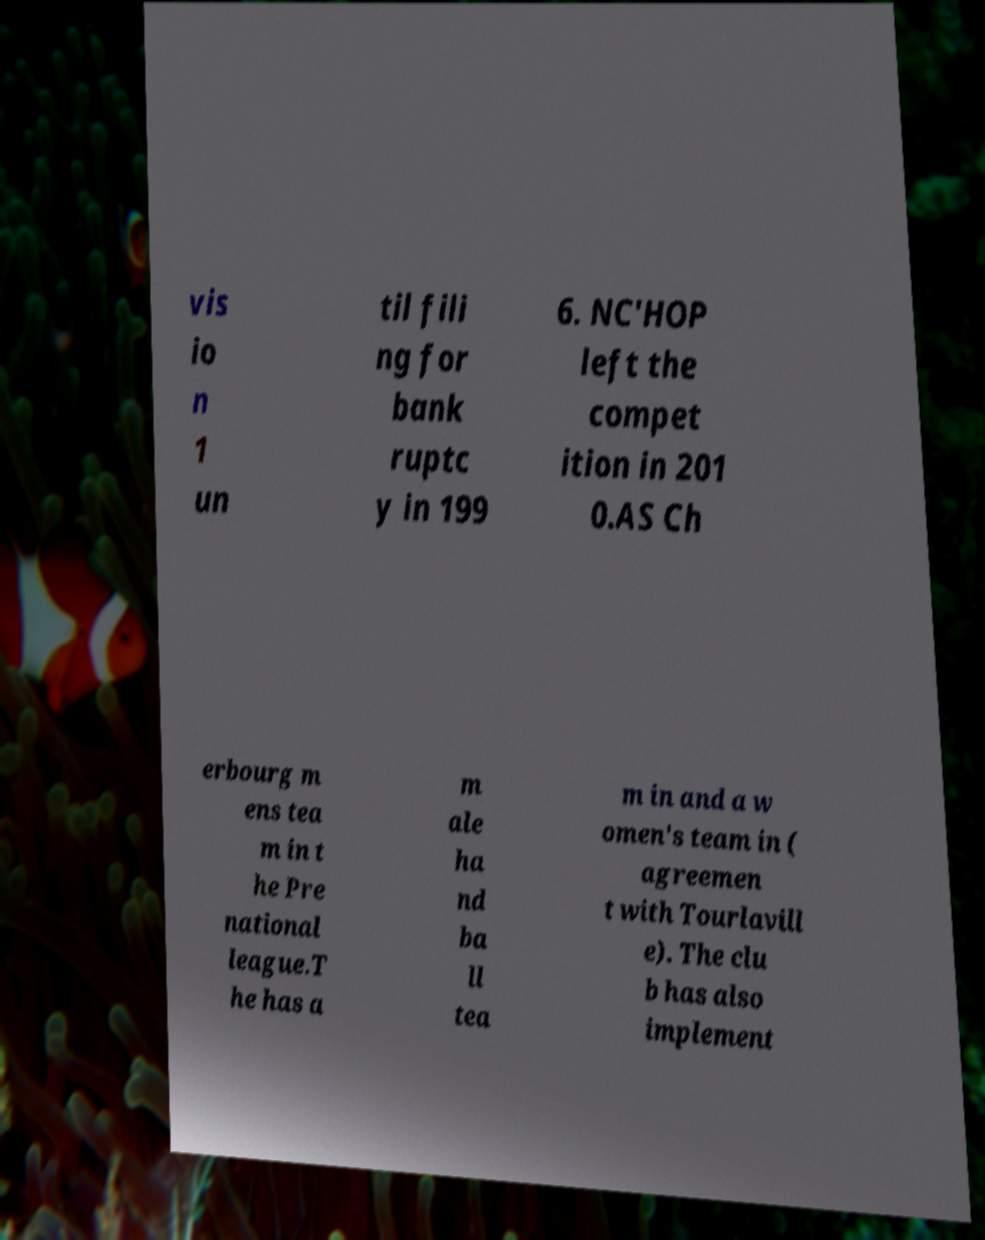Please identify and transcribe the text found in this image. vis io n 1 un til fili ng for bank ruptc y in 199 6. NC'HOP left the compet ition in 201 0.AS Ch erbourg m ens tea m in t he Pre national league.T he has a m ale ha nd ba ll tea m in and a w omen's team in ( agreemen t with Tourlavill e). The clu b has also implement 